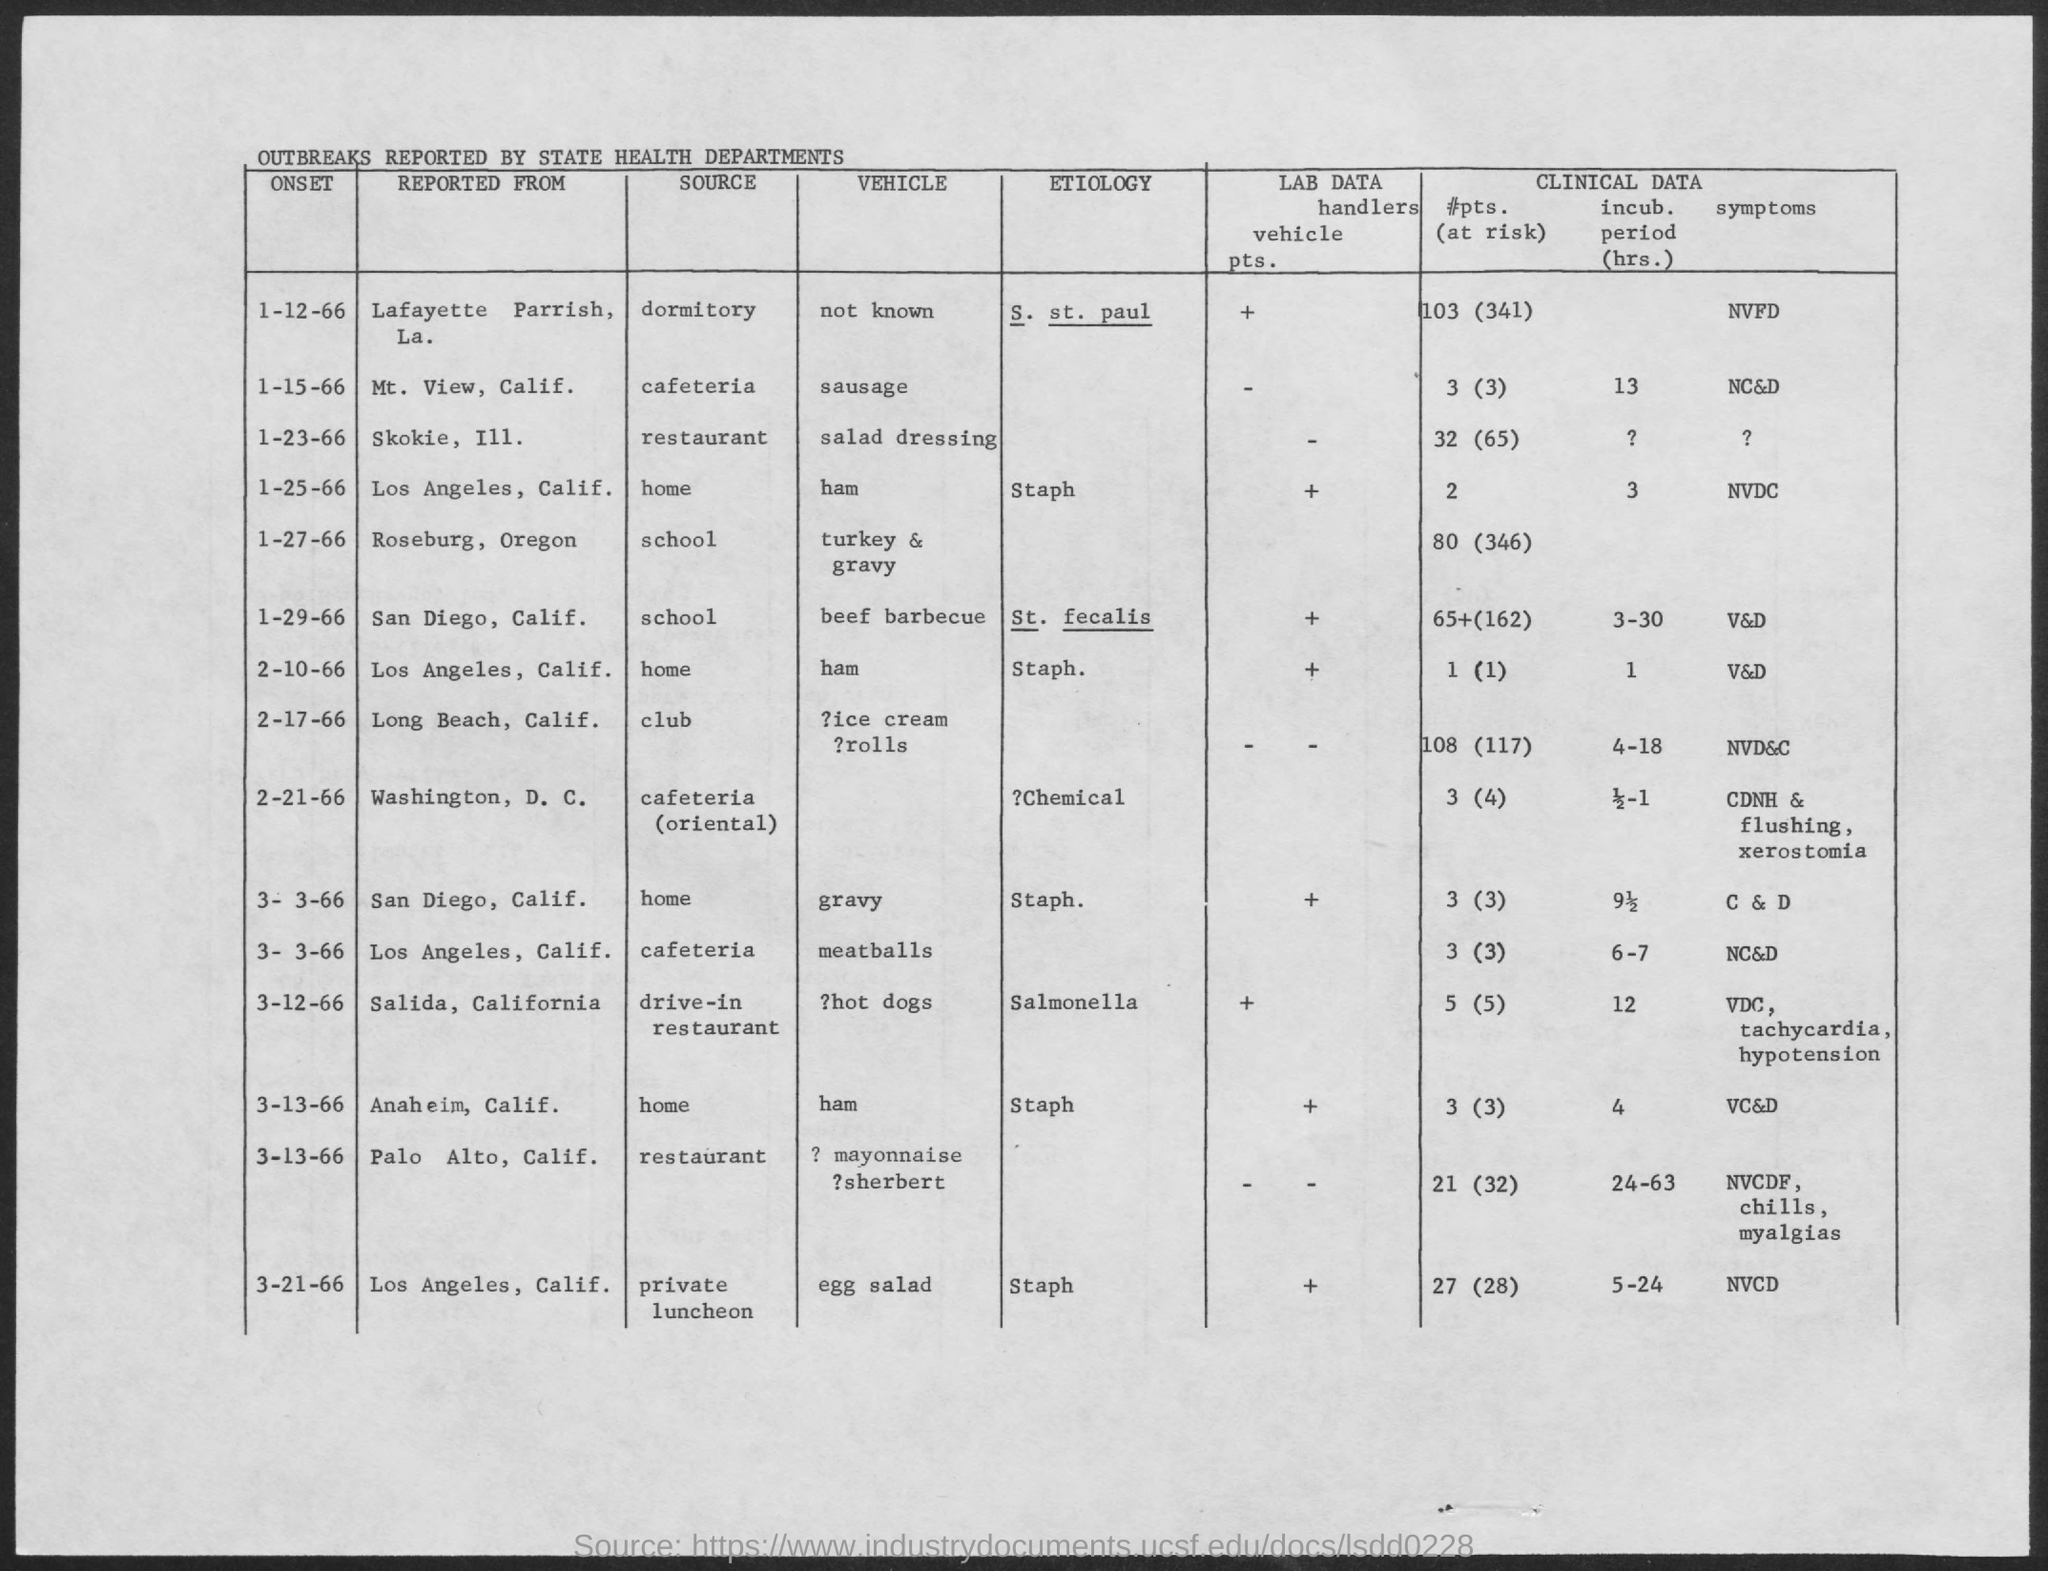What is the Source of outbreak reported from Lafayette parrish, La.?
Give a very brief answer. Dormitory. What is the etiology of outbreak reported from Lafayette parrish, La.?
Keep it short and to the point. S. ST. Paul. What is the vehicle of outbreak reported from Lafayette parrish, La.?
Provide a succinct answer. Not known. What is the Source of outbreak reported from Mt. View, Calif.?
Provide a succinct answer. Cafeteria. What is the vehicle of outbreak reported from Mt. View, Calif.?
Make the answer very short. Sausage. What is the Source of outbreak reported from Skokie, Ill.?
Ensure brevity in your answer.  Restaurant. What is the vehicle of outbreak reported from Skokie, Ill.?
Ensure brevity in your answer.  Salad dressing. 